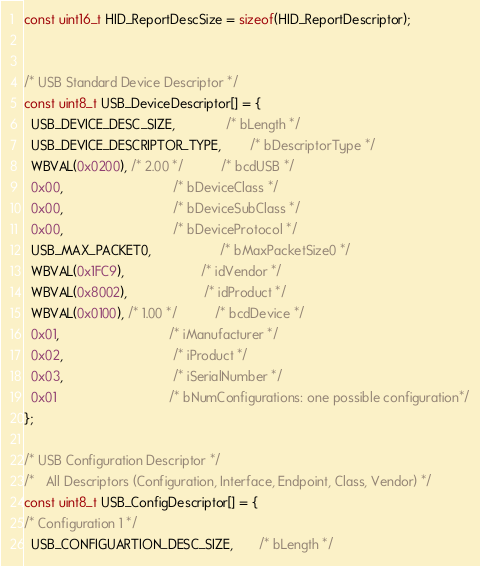Convert code to text. <code><loc_0><loc_0><loc_500><loc_500><_C_>const uint16_t HID_ReportDescSize = sizeof(HID_ReportDescriptor);


/* USB Standard Device Descriptor */
const uint8_t USB_DeviceDescriptor[] = {
  USB_DEVICE_DESC_SIZE,              /* bLength */
  USB_DEVICE_DESCRIPTOR_TYPE,        /* bDescriptorType */
  WBVAL(0x0200), /* 2.00 */          /* bcdUSB */
  0x00,                              /* bDeviceClass */
  0x00,                              /* bDeviceSubClass */
  0x00,                              /* bDeviceProtocol */
  USB_MAX_PACKET0,                   /* bMaxPacketSize0 */
  WBVAL(0x1FC9),                     /* idVendor */
  WBVAL(0x8002),                     /* idProduct */
  WBVAL(0x0100), /* 1.00 */          /* bcdDevice */
  0x01,                              /* iManufacturer */
  0x02,                              /* iProduct */
  0x03,                              /* iSerialNumber */
  0x01                               /* bNumConfigurations: one possible configuration*/
};

/* USB Configuration Descriptor */
/*   All Descriptors (Configuration, Interface, Endpoint, Class, Vendor) */
const uint8_t USB_ConfigDescriptor[] = {
/* Configuration 1 */
  USB_CONFIGUARTION_DESC_SIZE,       /* bLength */</code> 